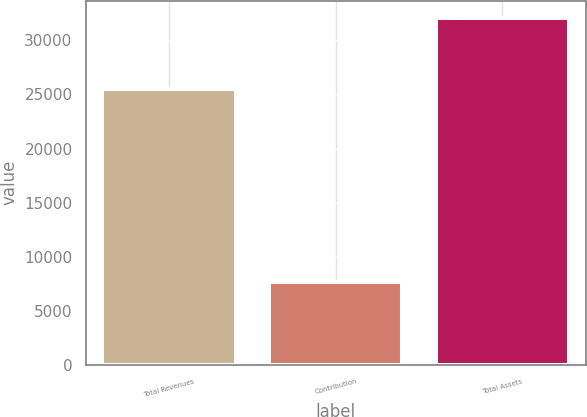Convert chart to OTSL. <chart><loc_0><loc_0><loc_500><loc_500><bar_chart><fcel>Total Revenues<fcel>Contribution<fcel>Total Assets<nl><fcel>25512<fcel>7712<fcel>32079<nl></chart> 